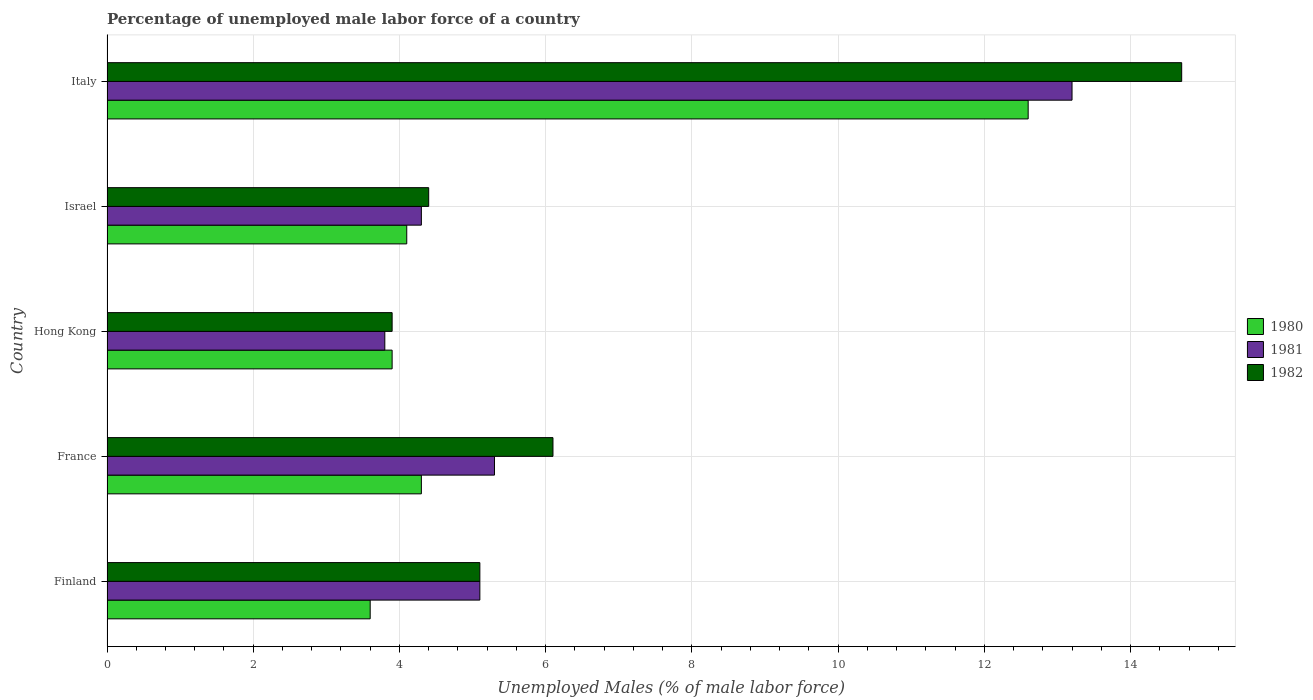How many different coloured bars are there?
Give a very brief answer. 3. Are the number of bars per tick equal to the number of legend labels?
Offer a terse response. Yes. In how many cases, is the number of bars for a given country not equal to the number of legend labels?
Provide a short and direct response. 0. What is the percentage of unemployed male labor force in 1981 in Finland?
Offer a terse response. 5.1. Across all countries, what is the maximum percentage of unemployed male labor force in 1980?
Offer a very short reply. 12.6. Across all countries, what is the minimum percentage of unemployed male labor force in 1981?
Offer a very short reply. 3.8. In which country was the percentage of unemployed male labor force in 1980 maximum?
Ensure brevity in your answer.  Italy. What is the total percentage of unemployed male labor force in 1982 in the graph?
Your response must be concise. 34.2. What is the difference between the percentage of unemployed male labor force in 1980 in Hong Kong and that in Italy?
Make the answer very short. -8.7. What is the difference between the percentage of unemployed male labor force in 1980 in Italy and the percentage of unemployed male labor force in 1982 in Finland?
Keep it short and to the point. 7.5. What is the average percentage of unemployed male labor force in 1980 per country?
Your answer should be very brief. 5.7. What is the difference between the percentage of unemployed male labor force in 1981 and percentage of unemployed male labor force in 1980 in Finland?
Provide a succinct answer. 1.5. In how many countries, is the percentage of unemployed male labor force in 1981 greater than 5.6 %?
Your answer should be compact. 1. What is the ratio of the percentage of unemployed male labor force in 1981 in Finland to that in Italy?
Offer a very short reply. 0.39. Is the percentage of unemployed male labor force in 1980 in France less than that in Italy?
Ensure brevity in your answer.  Yes. What is the difference between the highest and the second highest percentage of unemployed male labor force in 1982?
Keep it short and to the point. 8.6. What is the difference between the highest and the lowest percentage of unemployed male labor force in 1980?
Give a very brief answer. 9. In how many countries, is the percentage of unemployed male labor force in 1982 greater than the average percentage of unemployed male labor force in 1982 taken over all countries?
Your answer should be compact. 1. Is the sum of the percentage of unemployed male labor force in 1982 in Finland and France greater than the maximum percentage of unemployed male labor force in 1980 across all countries?
Make the answer very short. No. What does the 3rd bar from the top in Italy represents?
Give a very brief answer. 1980. How many bars are there?
Ensure brevity in your answer.  15. What is the difference between two consecutive major ticks on the X-axis?
Ensure brevity in your answer.  2. Does the graph contain grids?
Give a very brief answer. Yes. How are the legend labels stacked?
Your response must be concise. Vertical. What is the title of the graph?
Provide a succinct answer. Percentage of unemployed male labor force of a country. Does "1975" appear as one of the legend labels in the graph?
Ensure brevity in your answer.  No. What is the label or title of the X-axis?
Your response must be concise. Unemployed Males (% of male labor force). What is the label or title of the Y-axis?
Your response must be concise. Country. What is the Unemployed Males (% of male labor force) of 1980 in Finland?
Provide a succinct answer. 3.6. What is the Unemployed Males (% of male labor force) of 1981 in Finland?
Provide a succinct answer. 5.1. What is the Unemployed Males (% of male labor force) of 1982 in Finland?
Provide a succinct answer. 5.1. What is the Unemployed Males (% of male labor force) of 1980 in France?
Provide a succinct answer. 4.3. What is the Unemployed Males (% of male labor force) of 1981 in France?
Your answer should be very brief. 5.3. What is the Unemployed Males (% of male labor force) of 1982 in France?
Ensure brevity in your answer.  6.1. What is the Unemployed Males (% of male labor force) in 1980 in Hong Kong?
Your answer should be very brief. 3.9. What is the Unemployed Males (% of male labor force) in 1981 in Hong Kong?
Keep it short and to the point. 3.8. What is the Unemployed Males (% of male labor force) of 1982 in Hong Kong?
Keep it short and to the point. 3.9. What is the Unemployed Males (% of male labor force) in 1980 in Israel?
Offer a very short reply. 4.1. What is the Unemployed Males (% of male labor force) in 1981 in Israel?
Make the answer very short. 4.3. What is the Unemployed Males (% of male labor force) in 1982 in Israel?
Offer a terse response. 4.4. What is the Unemployed Males (% of male labor force) in 1980 in Italy?
Your response must be concise. 12.6. What is the Unemployed Males (% of male labor force) of 1981 in Italy?
Offer a terse response. 13.2. What is the Unemployed Males (% of male labor force) of 1982 in Italy?
Provide a short and direct response. 14.7. Across all countries, what is the maximum Unemployed Males (% of male labor force) of 1980?
Provide a succinct answer. 12.6. Across all countries, what is the maximum Unemployed Males (% of male labor force) in 1981?
Make the answer very short. 13.2. Across all countries, what is the maximum Unemployed Males (% of male labor force) in 1982?
Offer a very short reply. 14.7. Across all countries, what is the minimum Unemployed Males (% of male labor force) of 1980?
Give a very brief answer. 3.6. Across all countries, what is the minimum Unemployed Males (% of male labor force) of 1981?
Your response must be concise. 3.8. Across all countries, what is the minimum Unemployed Males (% of male labor force) of 1982?
Ensure brevity in your answer.  3.9. What is the total Unemployed Males (% of male labor force) in 1980 in the graph?
Provide a short and direct response. 28.5. What is the total Unemployed Males (% of male labor force) in 1981 in the graph?
Provide a succinct answer. 31.7. What is the total Unemployed Males (% of male labor force) of 1982 in the graph?
Offer a very short reply. 34.2. What is the difference between the Unemployed Males (% of male labor force) in 1980 in Finland and that in Hong Kong?
Keep it short and to the point. -0.3. What is the difference between the Unemployed Males (% of male labor force) in 1982 in Finland and that in Hong Kong?
Your answer should be compact. 1.2. What is the difference between the Unemployed Males (% of male labor force) in 1980 in Finland and that in Israel?
Your answer should be very brief. -0.5. What is the difference between the Unemployed Males (% of male labor force) in 1981 in Finland and that in Israel?
Your answer should be compact. 0.8. What is the difference between the Unemployed Males (% of male labor force) in 1980 in Finland and that in Italy?
Give a very brief answer. -9. What is the difference between the Unemployed Males (% of male labor force) in 1981 in Finland and that in Italy?
Your answer should be compact. -8.1. What is the difference between the Unemployed Males (% of male labor force) in 1982 in Finland and that in Italy?
Your answer should be very brief. -9.6. What is the difference between the Unemployed Males (% of male labor force) in 1980 in France and that in Israel?
Ensure brevity in your answer.  0.2. What is the difference between the Unemployed Males (% of male labor force) of 1982 in France and that in Italy?
Give a very brief answer. -8.6. What is the difference between the Unemployed Males (% of male labor force) of 1981 in Hong Kong and that in Israel?
Keep it short and to the point. -0.5. What is the difference between the Unemployed Males (% of male labor force) of 1982 in Hong Kong and that in Israel?
Make the answer very short. -0.5. What is the difference between the Unemployed Males (% of male labor force) of 1980 in Hong Kong and that in Italy?
Keep it short and to the point. -8.7. What is the difference between the Unemployed Males (% of male labor force) of 1981 in Hong Kong and that in Italy?
Make the answer very short. -9.4. What is the difference between the Unemployed Males (% of male labor force) in 1982 in Hong Kong and that in Italy?
Provide a succinct answer. -10.8. What is the difference between the Unemployed Males (% of male labor force) of 1980 in Israel and that in Italy?
Offer a very short reply. -8.5. What is the difference between the Unemployed Males (% of male labor force) in 1980 in Finland and the Unemployed Males (% of male labor force) in 1981 in France?
Your answer should be compact. -1.7. What is the difference between the Unemployed Males (% of male labor force) in 1980 in Finland and the Unemployed Males (% of male labor force) in 1982 in France?
Your answer should be very brief. -2.5. What is the difference between the Unemployed Males (% of male labor force) of 1980 in Finland and the Unemployed Males (% of male labor force) of 1981 in Hong Kong?
Ensure brevity in your answer.  -0.2. What is the difference between the Unemployed Males (% of male labor force) in 1981 in Finland and the Unemployed Males (% of male labor force) in 1982 in Hong Kong?
Your answer should be very brief. 1.2. What is the difference between the Unemployed Males (% of male labor force) in 1981 in Finland and the Unemployed Males (% of male labor force) in 1982 in Israel?
Give a very brief answer. 0.7. What is the difference between the Unemployed Males (% of male labor force) of 1980 in Finland and the Unemployed Males (% of male labor force) of 1982 in Italy?
Keep it short and to the point. -11.1. What is the difference between the Unemployed Males (% of male labor force) in 1981 in Finland and the Unemployed Males (% of male labor force) in 1982 in Italy?
Your answer should be very brief. -9.6. What is the difference between the Unemployed Males (% of male labor force) of 1980 in France and the Unemployed Males (% of male labor force) of 1982 in Hong Kong?
Provide a short and direct response. 0.4. What is the difference between the Unemployed Males (% of male labor force) in 1981 in France and the Unemployed Males (% of male labor force) in 1982 in Israel?
Your answer should be compact. 0.9. What is the difference between the Unemployed Males (% of male labor force) in 1980 in France and the Unemployed Males (% of male labor force) in 1982 in Italy?
Offer a terse response. -10.4. What is the difference between the Unemployed Males (% of male labor force) of 1980 in Hong Kong and the Unemployed Males (% of male labor force) of 1981 in Israel?
Your response must be concise. -0.4. What is the difference between the Unemployed Males (% of male labor force) in 1981 in Hong Kong and the Unemployed Males (% of male labor force) in 1982 in Israel?
Your answer should be compact. -0.6. What is the difference between the Unemployed Males (% of male labor force) in 1980 in Hong Kong and the Unemployed Males (% of male labor force) in 1981 in Italy?
Ensure brevity in your answer.  -9.3. What is the difference between the Unemployed Males (% of male labor force) in 1980 in Israel and the Unemployed Males (% of male labor force) in 1981 in Italy?
Make the answer very short. -9.1. What is the difference between the Unemployed Males (% of male labor force) in 1980 in Israel and the Unemployed Males (% of male labor force) in 1982 in Italy?
Ensure brevity in your answer.  -10.6. What is the difference between the Unemployed Males (% of male labor force) of 1981 in Israel and the Unemployed Males (% of male labor force) of 1982 in Italy?
Keep it short and to the point. -10.4. What is the average Unemployed Males (% of male labor force) of 1981 per country?
Ensure brevity in your answer.  6.34. What is the average Unemployed Males (% of male labor force) of 1982 per country?
Give a very brief answer. 6.84. What is the difference between the Unemployed Males (% of male labor force) in 1980 and Unemployed Males (% of male labor force) in 1982 in Finland?
Make the answer very short. -1.5. What is the difference between the Unemployed Males (% of male labor force) in 1981 and Unemployed Males (% of male labor force) in 1982 in France?
Make the answer very short. -0.8. What is the difference between the Unemployed Males (% of male labor force) of 1980 and Unemployed Males (% of male labor force) of 1981 in Hong Kong?
Your response must be concise. 0.1. What is the difference between the Unemployed Males (% of male labor force) of 1981 and Unemployed Males (% of male labor force) of 1982 in Hong Kong?
Your answer should be compact. -0.1. What is the difference between the Unemployed Males (% of male labor force) of 1980 and Unemployed Males (% of male labor force) of 1981 in Italy?
Give a very brief answer. -0.6. What is the ratio of the Unemployed Males (% of male labor force) in 1980 in Finland to that in France?
Ensure brevity in your answer.  0.84. What is the ratio of the Unemployed Males (% of male labor force) of 1981 in Finland to that in France?
Provide a short and direct response. 0.96. What is the ratio of the Unemployed Males (% of male labor force) of 1982 in Finland to that in France?
Make the answer very short. 0.84. What is the ratio of the Unemployed Males (% of male labor force) of 1980 in Finland to that in Hong Kong?
Keep it short and to the point. 0.92. What is the ratio of the Unemployed Males (% of male labor force) in 1981 in Finland to that in Hong Kong?
Provide a succinct answer. 1.34. What is the ratio of the Unemployed Males (% of male labor force) of 1982 in Finland to that in Hong Kong?
Provide a short and direct response. 1.31. What is the ratio of the Unemployed Males (% of male labor force) of 1980 in Finland to that in Israel?
Provide a succinct answer. 0.88. What is the ratio of the Unemployed Males (% of male labor force) in 1981 in Finland to that in Israel?
Your answer should be compact. 1.19. What is the ratio of the Unemployed Males (% of male labor force) in 1982 in Finland to that in Israel?
Offer a very short reply. 1.16. What is the ratio of the Unemployed Males (% of male labor force) of 1980 in Finland to that in Italy?
Offer a very short reply. 0.29. What is the ratio of the Unemployed Males (% of male labor force) in 1981 in Finland to that in Italy?
Give a very brief answer. 0.39. What is the ratio of the Unemployed Males (% of male labor force) in 1982 in Finland to that in Italy?
Your answer should be compact. 0.35. What is the ratio of the Unemployed Males (% of male labor force) of 1980 in France to that in Hong Kong?
Offer a terse response. 1.1. What is the ratio of the Unemployed Males (% of male labor force) in 1981 in France to that in Hong Kong?
Offer a terse response. 1.39. What is the ratio of the Unemployed Males (% of male labor force) in 1982 in France to that in Hong Kong?
Provide a short and direct response. 1.56. What is the ratio of the Unemployed Males (% of male labor force) of 1980 in France to that in Israel?
Your answer should be very brief. 1.05. What is the ratio of the Unemployed Males (% of male labor force) in 1981 in France to that in Israel?
Make the answer very short. 1.23. What is the ratio of the Unemployed Males (% of male labor force) in 1982 in France to that in Israel?
Your response must be concise. 1.39. What is the ratio of the Unemployed Males (% of male labor force) of 1980 in France to that in Italy?
Provide a short and direct response. 0.34. What is the ratio of the Unemployed Males (% of male labor force) in 1981 in France to that in Italy?
Your response must be concise. 0.4. What is the ratio of the Unemployed Males (% of male labor force) of 1982 in France to that in Italy?
Provide a succinct answer. 0.41. What is the ratio of the Unemployed Males (% of male labor force) in 1980 in Hong Kong to that in Israel?
Make the answer very short. 0.95. What is the ratio of the Unemployed Males (% of male labor force) in 1981 in Hong Kong to that in Israel?
Give a very brief answer. 0.88. What is the ratio of the Unemployed Males (% of male labor force) in 1982 in Hong Kong to that in Israel?
Give a very brief answer. 0.89. What is the ratio of the Unemployed Males (% of male labor force) of 1980 in Hong Kong to that in Italy?
Provide a succinct answer. 0.31. What is the ratio of the Unemployed Males (% of male labor force) in 1981 in Hong Kong to that in Italy?
Offer a terse response. 0.29. What is the ratio of the Unemployed Males (% of male labor force) in 1982 in Hong Kong to that in Italy?
Keep it short and to the point. 0.27. What is the ratio of the Unemployed Males (% of male labor force) in 1980 in Israel to that in Italy?
Offer a very short reply. 0.33. What is the ratio of the Unemployed Males (% of male labor force) in 1981 in Israel to that in Italy?
Your answer should be very brief. 0.33. What is the ratio of the Unemployed Males (% of male labor force) in 1982 in Israel to that in Italy?
Make the answer very short. 0.3. What is the difference between the highest and the second highest Unemployed Males (% of male labor force) in 1980?
Offer a terse response. 8.3. What is the difference between the highest and the second highest Unemployed Males (% of male labor force) in 1982?
Provide a short and direct response. 8.6. What is the difference between the highest and the lowest Unemployed Males (% of male labor force) of 1980?
Keep it short and to the point. 9. What is the difference between the highest and the lowest Unemployed Males (% of male labor force) in 1981?
Provide a succinct answer. 9.4. 